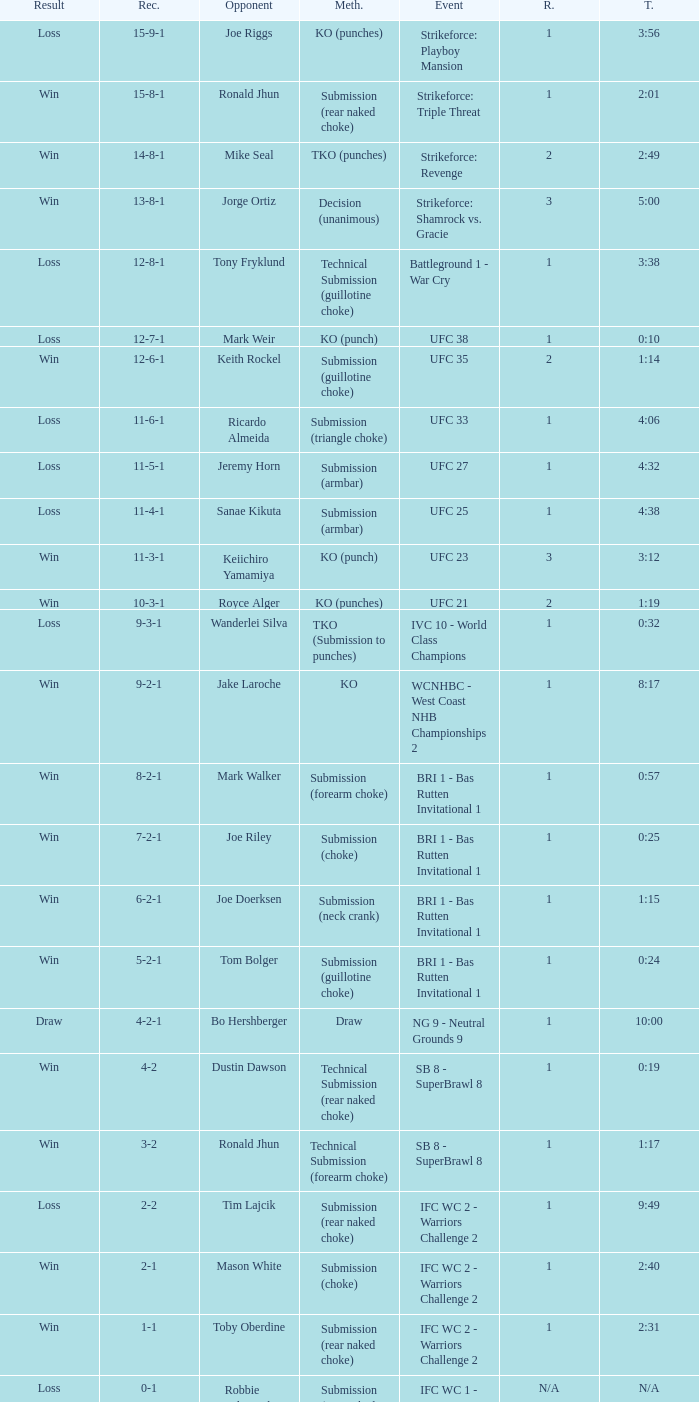When battling keith rockel, what was the record? 12-6-1. 